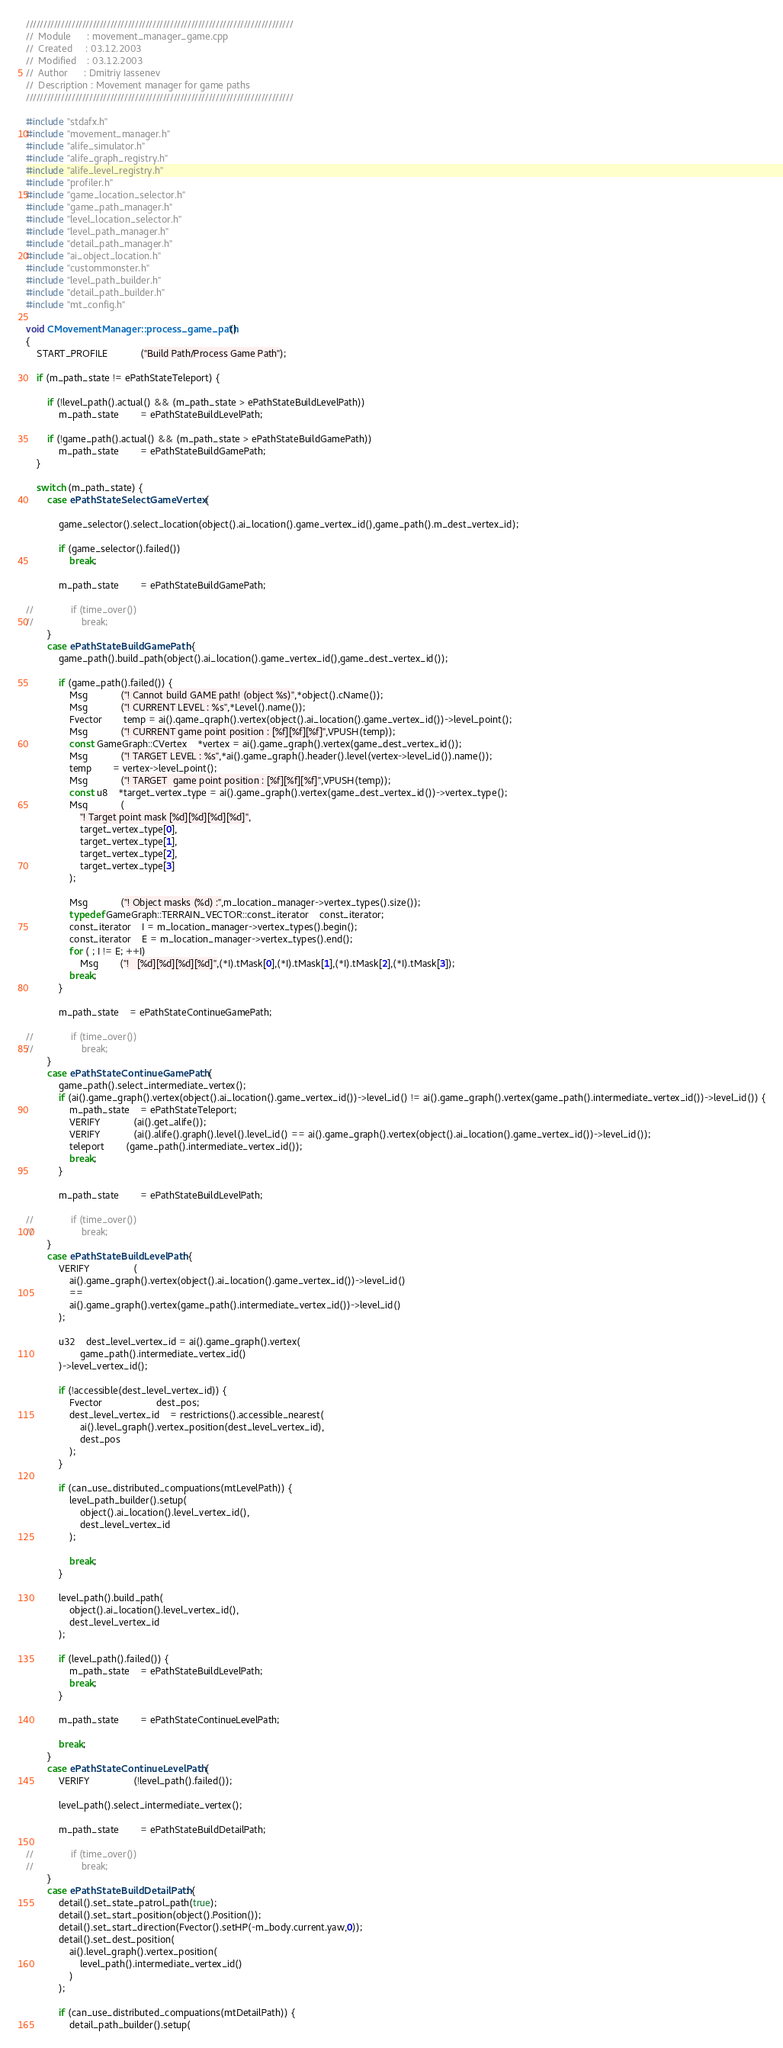<code> <loc_0><loc_0><loc_500><loc_500><_C++_>////////////////////////////////////////////////////////////////////////////
//	Module 		: movement_manager_game.cpp
//	Created 	: 03.12.2003
//  Modified 	: 03.12.2003
//	Author		: Dmitriy Iassenev
//	Description : Movement manager for game paths
////////////////////////////////////////////////////////////////////////////

#include "stdafx.h"
#include "movement_manager.h"
#include "alife_simulator.h"
#include "alife_graph_registry.h"
#include "alife_level_registry.h"
#include "profiler.h"
#include "game_location_selector.h"
#include "game_path_manager.h"
#include "level_location_selector.h"
#include "level_path_manager.h"
#include "detail_path_manager.h"
#include "ai_object_location.h"
#include "custommonster.h"
#include "level_path_builder.h"
#include "detail_path_builder.h"
#include "mt_config.h"

void CMovementManager::process_game_path()
{
	START_PROFILE			("Build Path/Process Game Path");

	if (m_path_state != ePathStateTeleport) {

		if (!level_path().actual() && (m_path_state > ePathStateBuildLevelPath))
			m_path_state		= ePathStateBuildLevelPath;

		if (!game_path().actual() && (m_path_state > ePathStateBuildGamePath))
			m_path_state		= ePathStateBuildGamePath;
	}

	switch (m_path_state) {
		case ePathStateSelectGameVertex : {

			game_selector().select_location(object().ai_location().game_vertex_id(),game_path().m_dest_vertex_id);

			if (game_selector().failed())
				break;

			m_path_state		= ePathStateBuildGamePath;

//				if (time_over())
//					break;
		}
		case ePathStateBuildGamePath : {
			game_path().build_path(object().ai_location().game_vertex_id(),game_dest_vertex_id());

			if (game_path().failed()) {
				Msg			("! Cannot build GAME path! (object %s)",*object().cName());
				Msg			("! CURRENT LEVEL : %s",*Level().name());
				Fvector		temp = ai().game_graph().vertex(object().ai_location().game_vertex_id())->level_point();
				Msg			("! CURRENT game point position : [%f][%f][%f]",VPUSH(temp));
				const GameGraph::CVertex	*vertex = ai().game_graph().vertex(game_dest_vertex_id());
				Msg			("! TARGET LEVEL : %s",*ai().game_graph().header().level(vertex->level_id()).name());
				temp		= vertex->level_point();
				Msg			("! TARGET  game point position : [%f][%f][%f]",VPUSH(temp));
				const u8	*target_vertex_type = ai().game_graph().vertex(game_dest_vertex_id())->vertex_type();
				Msg			(
					"! Target point mask [%d][%d][%d][%d]",
					target_vertex_type[0],
					target_vertex_type[1],
					target_vertex_type[2],
					target_vertex_type[3]
				);

				Msg			("! Object masks (%d) :",m_location_manager->vertex_types().size());
				typedef GameGraph::TERRAIN_VECTOR::const_iterator	const_iterator;
				const_iterator	I = m_location_manager->vertex_types().begin();
				const_iterator	E = m_location_manager->vertex_types().end();
				for ( ; I != E; ++I)
					Msg		("!   [%d][%d][%d][%d]",(*I).tMask[0],(*I).tMask[1],(*I).tMask[2],(*I).tMask[3]);
				break;
			}
			
			m_path_state	= ePathStateContinueGamePath;
			
//				if (time_over())
//					break;
		}
		case ePathStateContinueGamePath : {
			game_path().select_intermediate_vertex();
			if (ai().game_graph().vertex(object().ai_location().game_vertex_id())->level_id() != ai().game_graph().vertex(game_path().intermediate_vertex_id())->level_id()) {
				m_path_state	= ePathStateTeleport;
				VERIFY			(ai().get_alife());
				VERIFY			(ai().alife().graph().level().level_id() == ai().game_graph().vertex(object().ai_location().game_vertex_id())->level_id());
				teleport		(game_path().intermediate_vertex_id());
				break;
			}
			
			m_path_state		= ePathStateBuildLevelPath;
			
//				if (time_over())
//					break;
		}
		case ePathStateBuildLevelPath : {
			VERIFY				(
				ai().game_graph().vertex(object().ai_location().game_vertex_id())->level_id() 
				== 
				ai().game_graph().vertex(game_path().intermediate_vertex_id())->level_id()
			);

			u32	dest_level_vertex_id = ai().game_graph().vertex(
					game_path().intermediate_vertex_id()
			)->level_vertex_id();

			if (!accessible(dest_level_vertex_id)) {
				Fvector					dest_pos;
				dest_level_vertex_id	= restrictions().accessible_nearest(
					ai().level_graph().vertex_position(dest_level_vertex_id),
					dest_pos
				);
			}

			if (can_use_distributed_compuations(mtLevelPath)) {
				level_path_builder().setup(
					object().ai_location().level_vertex_id(),
					dest_level_vertex_id
				);

				break;
			}

			level_path().build_path(
				object().ai_location().level_vertex_id(),
				dest_level_vertex_id
			);

			if (level_path().failed()) {
				m_path_state	= ePathStateBuildLevelPath;
				break;
			}
			
			m_path_state		= ePathStateContinueLevelPath;
			
			break;
		}
		case ePathStateContinueLevelPath : {
			VERIFY				(!level_path().failed());

			level_path().select_intermediate_vertex();
			
			m_path_state		= ePathStateBuildDetailPath;
			
//				if (time_over())
//					break;
		}
		case ePathStateBuildDetailPath : {
			detail().set_state_patrol_path(true);
			detail().set_start_position(object().Position());
			detail().set_start_direction(Fvector().setHP(-m_body.current.yaw,0));
			detail().set_dest_position( 
				ai().level_graph().vertex_position(
					level_path().intermediate_vertex_id()
				)
			);

			if (can_use_distributed_compuations(mtDetailPath)) {
				detail_path_builder().setup(</code> 